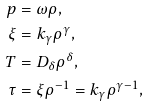<formula> <loc_0><loc_0><loc_500><loc_500>p & = \omega \rho , \\ \xi & = k _ { \gamma } \rho ^ { \gamma } , \\ T & = D _ { \delta } \rho ^ { \delta } , \\ \tau & = \xi \rho ^ { - 1 } = k _ { \gamma } \rho ^ { \gamma - 1 } ,</formula> 